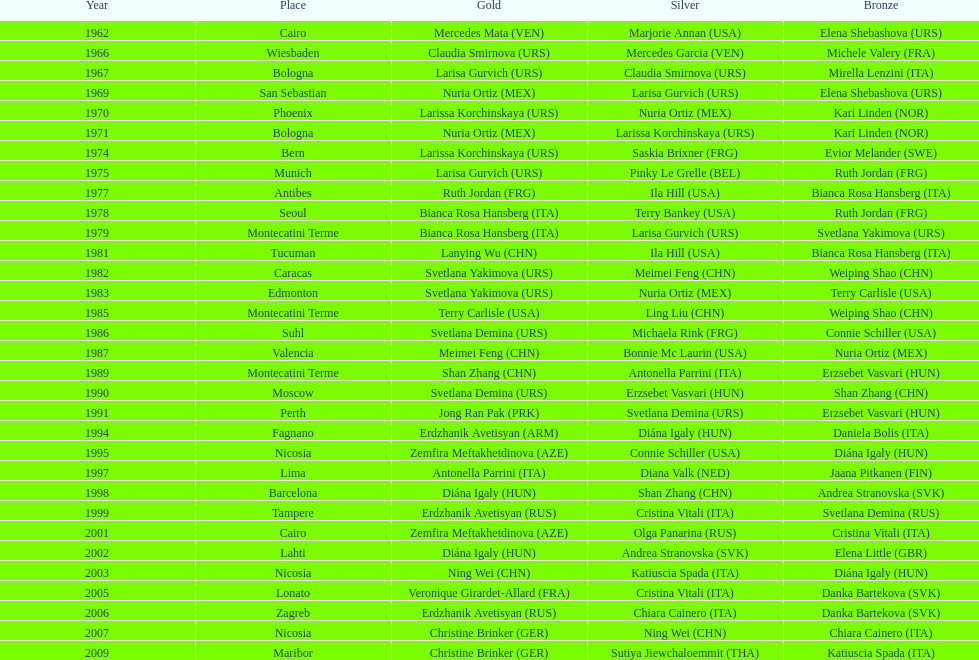What is the aggregate number of wins for the united states in gold, silver, and bronze? 9. 